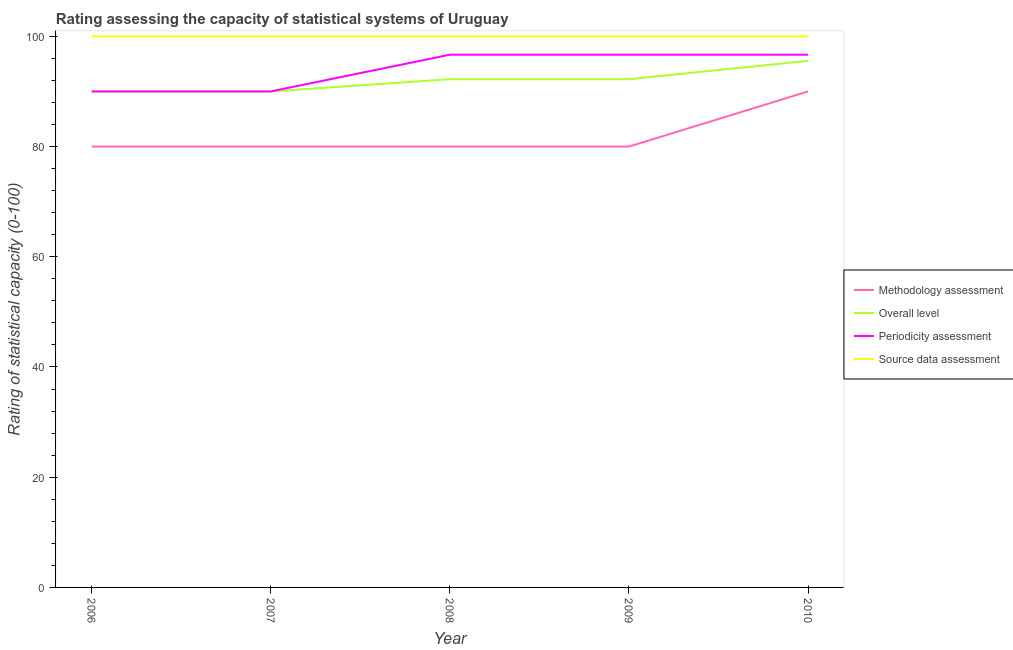How many different coloured lines are there?
Keep it short and to the point. 4. Does the line corresponding to periodicity assessment rating intersect with the line corresponding to source data assessment rating?
Your response must be concise. No. Is the number of lines equal to the number of legend labels?
Your answer should be compact. Yes. What is the overall level rating in 2008?
Give a very brief answer. 92.22. Across all years, what is the maximum overall level rating?
Provide a succinct answer. 95.56. Across all years, what is the minimum methodology assessment rating?
Offer a terse response. 80. In which year was the periodicity assessment rating maximum?
Provide a short and direct response. 2008. In which year was the periodicity assessment rating minimum?
Provide a short and direct response. 2006. What is the total overall level rating in the graph?
Your answer should be very brief. 460. What is the difference between the source data assessment rating in 2006 and that in 2007?
Offer a very short reply. 0. What is the difference between the periodicity assessment rating in 2009 and the overall level rating in 2008?
Ensure brevity in your answer.  4.44. What is the average periodicity assessment rating per year?
Keep it short and to the point. 94. In the year 2008, what is the difference between the periodicity assessment rating and source data assessment rating?
Keep it short and to the point. -3.33. In how many years, is the overall level rating greater than 84?
Provide a short and direct response. 5. What is the ratio of the periodicity assessment rating in 2009 to that in 2010?
Your answer should be very brief. 1. Is the periodicity assessment rating in 2006 less than that in 2009?
Provide a short and direct response. Yes. What is the difference between the highest and the lowest source data assessment rating?
Offer a very short reply. 0. In how many years, is the methodology assessment rating greater than the average methodology assessment rating taken over all years?
Provide a succinct answer. 1. Is it the case that in every year, the sum of the methodology assessment rating and source data assessment rating is greater than the sum of periodicity assessment rating and overall level rating?
Make the answer very short. No. Does the overall level rating monotonically increase over the years?
Provide a succinct answer. No. Is the source data assessment rating strictly greater than the overall level rating over the years?
Offer a very short reply. Yes. Is the source data assessment rating strictly less than the periodicity assessment rating over the years?
Provide a short and direct response. No. How many lines are there?
Offer a very short reply. 4. What is the difference between two consecutive major ticks on the Y-axis?
Offer a very short reply. 20. Does the graph contain any zero values?
Make the answer very short. No. How are the legend labels stacked?
Provide a short and direct response. Vertical. What is the title of the graph?
Give a very brief answer. Rating assessing the capacity of statistical systems of Uruguay. What is the label or title of the X-axis?
Provide a short and direct response. Year. What is the label or title of the Y-axis?
Provide a succinct answer. Rating of statistical capacity (0-100). What is the Rating of statistical capacity (0-100) of Methodology assessment in 2007?
Ensure brevity in your answer.  80. What is the Rating of statistical capacity (0-100) in Periodicity assessment in 2007?
Your answer should be very brief. 90. What is the Rating of statistical capacity (0-100) of Methodology assessment in 2008?
Provide a succinct answer. 80. What is the Rating of statistical capacity (0-100) of Overall level in 2008?
Your answer should be compact. 92.22. What is the Rating of statistical capacity (0-100) of Periodicity assessment in 2008?
Your response must be concise. 96.67. What is the Rating of statistical capacity (0-100) in Methodology assessment in 2009?
Give a very brief answer. 80. What is the Rating of statistical capacity (0-100) in Overall level in 2009?
Provide a succinct answer. 92.22. What is the Rating of statistical capacity (0-100) in Periodicity assessment in 2009?
Provide a succinct answer. 96.67. What is the Rating of statistical capacity (0-100) in Source data assessment in 2009?
Offer a very short reply. 100. What is the Rating of statistical capacity (0-100) of Overall level in 2010?
Keep it short and to the point. 95.56. What is the Rating of statistical capacity (0-100) in Periodicity assessment in 2010?
Your response must be concise. 96.67. What is the Rating of statistical capacity (0-100) of Source data assessment in 2010?
Your response must be concise. 100. Across all years, what is the maximum Rating of statistical capacity (0-100) in Methodology assessment?
Offer a very short reply. 90. Across all years, what is the maximum Rating of statistical capacity (0-100) in Overall level?
Offer a terse response. 95.56. Across all years, what is the maximum Rating of statistical capacity (0-100) in Periodicity assessment?
Offer a terse response. 96.67. Across all years, what is the minimum Rating of statistical capacity (0-100) of Methodology assessment?
Provide a short and direct response. 80. Across all years, what is the minimum Rating of statistical capacity (0-100) of Overall level?
Your answer should be compact. 90. Across all years, what is the minimum Rating of statistical capacity (0-100) in Periodicity assessment?
Your answer should be compact. 90. Across all years, what is the minimum Rating of statistical capacity (0-100) in Source data assessment?
Keep it short and to the point. 100. What is the total Rating of statistical capacity (0-100) of Methodology assessment in the graph?
Make the answer very short. 410. What is the total Rating of statistical capacity (0-100) of Overall level in the graph?
Give a very brief answer. 460. What is the total Rating of statistical capacity (0-100) of Periodicity assessment in the graph?
Offer a terse response. 470. What is the difference between the Rating of statistical capacity (0-100) of Methodology assessment in 2006 and that in 2007?
Make the answer very short. 0. What is the difference between the Rating of statistical capacity (0-100) of Periodicity assessment in 2006 and that in 2007?
Give a very brief answer. 0. What is the difference between the Rating of statistical capacity (0-100) in Overall level in 2006 and that in 2008?
Your answer should be compact. -2.22. What is the difference between the Rating of statistical capacity (0-100) in Periodicity assessment in 2006 and that in 2008?
Provide a succinct answer. -6.67. What is the difference between the Rating of statistical capacity (0-100) in Source data assessment in 2006 and that in 2008?
Give a very brief answer. 0. What is the difference between the Rating of statistical capacity (0-100) in Methodology assessment in 2006 and that in 2009?
Offer a terse response. 0. What is the difference between the Rating of statistical capacity (0-100) in Overall level in 2006 and that in 2009?
Keep it short and to the point. -2.22. What is the difference between the Rating of statistical capacity (0-100) of Periodicity assessment in 2006 and that in 2009?
Offer a terse response. -6.67. What is the difference between the Rating of statistical capacity (0-100) of Source data assessment in 2006 and that in 2009?
Keep it short and to the point. 0. What is the difference between the Rating of statistical capacity (0-100) in Overall level in 2006 and that in 2010?
Offer a terse response. -5.56. What is the difference between the Rating of statistical capacity (0-100) in Periodicity assessment in 2006 and that in 2010?
Ensure brevity in your answer.  -6.67. What is the difference between the Rating of statistical capacity (0-100) in Source data assessment in 2006 and that in 2010?
Make the answer very short. 0. What is the difference between the Rating of statistical capacity (0-100) in Overall level in 2007 and that in 2008?
Keep it short and to the point. -2.22. What is the difference between the Rating of statistical capacity (0-100) of Periodicity assessment in 2007 and that in 2008?
Provide a succinct answer. -6.67. What is the difference between the Rating of statistical capacity (0-100) of Methodology assessment in 2007 and that in 2009?
Provide a short and direct response. 0. What is the difference between the Rating of statistical capacity (0-100) of Overall level in 2007 and that in 2009?
Provide a succinct answer. -2.22. What is the difference between the Rating of statistical capacity (0-100) in Periodicity assessment in 2007 and that in 2009?
Provide a short and direct response. -6.67. What is the difference between the Rating of statistical capacity (0-100) in Methodology assessment in 2007 and that in 2010?
Keep it short and to the point. -10. What is the difference between the Rating of statistical capacity (0-100) of Overall level in 2007 and that in 2010?
Ensure brevity in your answer.  -5.56. What is the difference between the Rating of statistical capacity (0-100) of Periodicity assessment in 2007 and that in 2010?
Your answer should be compact. -6.67. What is the difference between the Rating of statistical capacity (0-100) of Overall level in 2008 and that in 2009?
Ensure brevity in your answer.  0. What is the difference between the Rating of statistical capacity (0-100) in Periodicity assessment in 2008 and that in 2009?
Your answer should be very brief. 0. What is the difference between the Rating of statistical capacity (0-100) of Source data assessment in 2008 and that in 2009?
Keep it short and to the point. 0. What is the difference between the Rating of statistical capacity (0-100) of Methodology assessment in 2008 and that in 2010?
Provide a succinct answer. -10. What is the difference between the Rating of statistical capacity (0-100) in Source data assessment in 2008 and that in 2010?
Keep it short and to the point. 0. What is the difference between the Rating of statistical capacity (0-100) of Methodology assessment in 2009 and that in 2010?
Provide a succinct answer. -10. What is the difference between the Rating of statistical capacity (0-100) of Overall level in 2009 and that in 2010?
Make the answer very short. -3.33. What is the difference between the Rating of statistical capacity (0-100) of Source data assessment in 2009 and that in 2010?
Ensure brevity in your answer.  0. What is the difference between the Rating of statistical capacity (0-100) of Overall level in 2006 and the Rating of statistical capacity (0-100) of Periodicity assessment in 2007?
Provide a succinct answer. 0. What is the difference between the Rating of statistical capacity (0-100) in Overall level in 2006 and the Rating of statistical capacity (0-100) in Source data assessment in 2007?
Offer a very short reply. -10. What is the difference between the Rating of statistical capacity (0-100) of Periodicity assessment in 2006 and the Rating of statistical capacity (0-100) of Source data assessment in 2007?
Provide a succinct answer. -10. What is the difference between the Rating of statistical capacity (0-100) in Methodology assessment in 2006 and the Rating of statistical capacity (0-100) in Overall level in 2008?
Your answer should be compact. -12.22. What is the difference between the Rating of statistical capacity (0-100) of Methodology assessment in 2006 and the Rating of statistical capacity (0-100) of Periodicity assessment in 2008?
Your response must be concise. -16.67. What is the difference between the Rating of statistical capacity (0-100) of Methodology assessment in 2006 and the Rating of statistical capacity (0-100) of Source data assessment in 2008?
Provide a short and direct response. -20. What is the difference between the Rating of statistical capacity (0-100) of Overall level in 2006 and the Rating of statistical capacity (0-100) of Periodicity assessment in 2008?
Your answer should be very brief. -6.67. What is the difference between the Rating of statistical capacity (0-100) in Methodology assessment in 2006 and the Rating of statistical capacity (0-100) in Overall level in 2009?
Provide a succinct answer. -12.22. What is the difference between the Rating of statistical capacity (0-100) in Methodology assessment in 2006 and the Rating of statistical capacity (0-100) in Periodicity assessment in 2009?
Ensure brevity in your answer.  -16.67. What is the difference between the Rating of statistical capacity (0-100) of Methodology assessment in 2006 and the Rating of statistical capacity (0-100) of Source data assessment in 2009?
Keep it short and to the point. -20. What is the difference between the Rating of statistical capacity (0-100) of Overall level in 2006 and the Rating of statistical capacity (0-100) of Periodicity assessment in 2009?
Give a very brief answer. -6.67. What is the difference between the Rating of statistical capacity (0-100) of Overall level in 2006 and the Rating of statistical capacity (0-100) of Source data assessment in 2009?
Give a very brief answer. -10. What is the difference between the Rating of statistical capacity (0-100) in Periodicity assessment in 2006 and the Rating of statistical capacity (0-100) in Source data assessment in 2009?
Provide a short and direct response. -10. What is the difference between the Rating of statistical capacity (0-100) of Methodology assessment in 2006 and the Rating of statistical capacity (0-100) of Overall level in 2010?
Offer a very short reply. -15.56. What is the difference between the Rating of statistical capacity (0-100) in Methodology assessment in 2006 and the Rating of statistical capacity (0-100) in Periodicity assessment in 2010?
Make the answer very short. -16.67. What is the difference between the Rating of statistical capacity (0-100) in Methodology assessment in 2006 and the Rating of statistical capacity (0-100) in Source data assessment in 2010?
Provide a succinct answer. -20. What is the difference between the Rating of statistical capacity (0-100) of Overall level in 2006 and the Rating of statistical capacity (0-100) of Periodicity assessment in 2010?
Offer a very short reply. -6.67. What is the difference between the Rating of statistical capacity (0-100) of Overall level in 2006 and the Rating of statistical capacity (0-100) of Source data assessment in 2010?
Your answer should be very brief. -10. What is the difference between the Rating of statistical capacity (0-100) of Methodology assessment in 2007 and the Rating of statistical capacity (0-100) of Overall level in 2008?
Your answer should be compact. -12.22. What is the difference between the Rating of statistical capacity (0-100) in Methodology assessment in 2007 and the Rating of statistical capacity (0-100) in Periodicity assessment in 2008?
Your response must be concise. -16.67. What is the difference between the Rating of statistical capacity (0-100) of Methodology assessment in 2007 and the Rating of statistical capacity (0-100) of Source data assessment in 2008?
Provide a short and direct response. -20. What is the difference between the Rating of statistical capacity (0-100) of Overall level in 2007 and the Rating of statistical capacity (0-100) of Periodicity assessment in 2008?
Keep it short and to the point. -6.67. What is the difference between the Rating of statistical capacity (0-100) in Overall level in 2007 and the Rating of statistical capacity (0-100) in Source data assessment in 2008?
Offer a very short reply. -10. What is the difference between the Rating of statistical capacity (0-100) of Periodicity assessment in 2007 and the Rating of statistical capacity (0-100) of Source data assessment in 2008?
Keep it short and to the point. -10. What is the difference between the Rating of statistical capacity (0-100) of Methodology assessment in 2007 and the Rating of statistical capacity (0-100) of Overall level in 2009?
Offer a very short reply. -12.22. What is the difference between the Rating of statistical capacity (0-100) in Methodology assessment in 2007 and the Rating of statistical capacity (0-100) in Periodicity assessment in 2009?
Offer a very short reply. -16.67. What is the difference between the Rating of statistical capacity (0-100) in Overall level in 2007 and the Rating of statistical capacity (0-100) in Periodicity assessment in 2009?
Offer a very short reply. -6.67. What is the difference between the Rating of statistical capacity (0-100) in Overall level in 2007 and the Rating of statistical capacity (0-100) in Source data assessment in 2009?
Give a very brief answer. -10. What is the difference between the Rating of statistical capacity (0-100) in Methodology assessment in 2007 and the Rating of statistical capacity (0-100) in Overall level in 2010?
Keep it short and to the point. -15.56. What is the difference between the Rating of statistical capacity (0-100) of Methodology assessment in 2007 and the Rating of statistical capacity (0-100) of Periodicity assessment in 2010?
Offer a terse response. -16.67. What is the difference between the Rating of statistical capacity (0-100) of Methodology assessment in 2007 and the Rating of statistical capacity (0-100) of Source data assessment in 2010?
Provide a short and direct response. -20. What is the difference between the Rating of statistical capacity (0-100) of Overall level in 2007 and the Rating of statistical capacity (0-100) of Periodicity assessment in 2010?
Your answer should be compact. -6.67. What is the difference between the Rating of statistical capacity (0-100) in Methodology assessment in 2008 and the Rating of statistical capacity (0-100) in Overall level in 2009?
Offer a terse response. -12.22. What is the difference between the Rating of statistical capacity (0-100) in Methodology assessment in 2008 and the Rating of statistical capacity (0-100) in Periodicity assessment in 2009?
Offer a terse response. -16.67. What is the difference between the Rating of statistical capacity (0-100) in Overall level in 2008 and the Rating of statistical capacity (0-100) in Periodicity assessment in 2009?
Offer a very short reply. -4.44. What is the difference between the Rating of statistical capacity (0-100) in Overall level in 2008 and the Rating of statistical capacity (0-100) in Source data assessment in 2009?
Ensure brevity in your answer.  -7.78. What is the difference between the Rating of statistical capacity (0-100) of Methodology assessment in 2008 and the Rating of statistical capacity (0-100) of Overall level in 2010?
Your response must be concise. -15.56. What is the difference between the Rating of statistical capacity (0-100) of Methodology assessment in 2008 and the Rating of statistical capacity (0-100) of Periodicity assessment in 2010?
Give a very brief answer. -16.67. What is the difference between the Rating of statistical capacity (0-100) in Methodology assessment in 2008 and the Rating of statistical capacity (0-100) in Source data assessment in 2010?
Provide a succinct answer. -20. What is the difference between the Rating of statistical capacity (0-100) of Overall level in 2008 and the Rating of statistical capacity (0-100) of Periodicity assessment in 2010?
Offer a terse response. -4.44. What is the difference between the Rating of statistical capacity (0-100) in Overall level in 2008 and the Rating of statistical capacity (0-100) in Source data assessment in 2010?
Your answer should be very brief. -7.78. What is the difference between the Rating of statistical capacity (0-100) in Methodology assessment in 2009 and the Rating of statistical capacity (0-100) in Overall level in 2010?
Your answer should be compact. -15.56. What is the difference between the Rating of statistical capacity (0-100) in Methodology assessment in 2009 and the Rating of statistical capacity (0-100) in Periodicity assessment in 2010?
Your response must be concise. -16.67. What is the difference between the Rating of statistical capacity (0-100) of Methodology assessment in 2009 and the Rating of statistical capacity (0-100) of Source data assessment in 2010?
Offer a very short reply. -20. What is the difference between the Rating of statistical capacity (0-100) of Overall level in 2009 and the Rating of statistical capacity (0-100) of Periodicity assessment in 2010?
Your answer should be very brief. -4.44. What is the difference between the Rating of statistical capacity (0-100) of Overall level in 2009 and the Rating of statistical capacity (0-100) of Source data assessment in 2010?
Make the answer very short. -7.78. What is the difference between the Rating of statistical capacity (0-100) in Periodicity assessment in 2009 and the Rating of statistical capacity (0-100) in Source data assessment in 2010?
Your response must be concise. -3.33. What is the average Rating of statistical capacity (0-100) in Overall level per year?
Ensure brevity in your answer.  92. What is the average Rating of statistical capacity (0-100) of Periodicity assessment per year?
Keep it short and to the point. 94. What is the average Rating of statistical capacity (0-100) of Source data assessment per year?
Your answer should be very brief. 100. In the year 2006, what is the difference between the Rating of statistical capacity (0-100) of Methodology assessment and Rating of statistical capacity (0-100) of Overall level?
Ensure brevity in your answer.  -10. In the year 2006, what is the difference between the Rating of statistical capacity (0-100) in Methodology assessment and Rating of statistical capacity (0-100) in Source data assessment?
Offer a very short reply. -20. In the year 2007, what is the difference between the Rating of statistical capacity (0-100) of Methodology assessment and Rating of statistical capacity (0-100) of Overall level?
Your answer should be compact. -10. In the year 2007, what is the difference between the Rating of statistical capacity (0-100) in Methodology assessment and Rating of statistical capacity (0-100) in Periodicity assessment?
Give a very brief answer. -10. In the year 2007, what is the difference between the Rating of statistical capacity (0-100) of Methodology assessment and Rating of statistical capacity (0-100) of Source data assessment?
Keep it short and to the point. -20. In the year 2007, what is the difference between the Rating of statistical capacity (0-100) in Overall level and Rating of statistical capacity (0-100) in Periodicity assessment?
Offer a terse response. 0. In the year 2008, what is the difference between the Rating of statistical capacity (0-100) of Methodology assessment and Rating of statistical capacity (0-100) of Overall level?
Offer a very short reply. -12.22. In the year 2008, what is the difference between the Rating of statistical capacity (0-100) of Methodology assessment and Rating of statistical capacity (0-100) of Periodicity assessment?
Your answer should be compact. -16.67. In the year 2008, what is the difference between the Rating of statistical capacity (0-100) of Methodology assessment and Rating of statistical capacity (0-100) of Source data assessment?
Give a very brief answer. -20. In the year 2008, what is the difference between the Rating of statistical capacity (0-100) in Overall level and Rating of statistical capacity (0-100) in Periodicity assessment?
Provide a succinct answer. -4.44. In the year 2008, what is the difference between the Rating of statistical capacity (0-100) in Overall level and Rating of statistical capacity (0-100) in Source data assessment?
Your answer should be compact. -7.78. In the year 2009, what is the difference between the Rating of statistical capacity (0-100) in Methodology assessment and Rating of statistical capacity (0-100) in Overall level?
Your response must be concise. -12.22. In the year 2009, what is the difference between the Rating of statistical capacity (0-100) in Methodology assessment and Rating of statistical capacity (0-100) in Periodicity assessment?
Your response must be concise. -16.67. In the year 2009, what is the difference between the Rating of statistical capacity (0-100) in Overall level and Rating of statistical capacity (0-100) in Periodicity assessment?
Your answer should be very brief. -4.44. In the year 2009, what is the difference between the Rating of statistical capacity (0-100) in Overall level and Rating of statistical capacity (0-100) in Source data assessment?
Your response must be concise. -7.78. In the year 2009, what is the difference between the Rating of statistical capacity (0-100) of Periodicity assessment and Rating of statistical capacity (0-100) of Source data assessment?
Offer a very short reply. -3.33. In the year 2010, what is the difference between the Rating of statistical capacity (0-100) of Methodology assessment and Rating of statistical capacity (0-100) of Overall level?
Ensure brevity in your answer.  -5.56. In the year 2010, what is the difference between the Rating of statistical capacity (0-100) in Methodology assessment and Rating of statistical capacity (0-100) in Periodicity assessment?
Your answer should be compact. -6.67. In the year 2010, what is the difference between the Rating of statistical capacity (0-100) of Methodology assessment and Rating of statistical capacity (0-100) of Source data assessment?
Your answer should be compact. -10. In the year 2010, what is the difference between the Rating of statistical capacity (0-100) of Overall level and Rating of statistical capacity (0-100) of Periodicity assessment?
Your response must be concise. -1.11. In the year 2010, what is the difference between the Rating of statistical capacity (0-100) of Overall level and Rating of statistical capacity (0-100) of Source data assessment?
Your answer should be compact. -4.44. In the year 2010, what is the difference between the Rating of statistical capacity (0-100) of Periodicity assessment and Rating of statistical capacity (0-100) of Source data assessment?
Keep it short and to the point. -3.33. What is the ratio of the Rating of statistical capacity (0-100) of Overall level in 2006 to that in 2007?
Provide a succinct answer. 1. What is the ratio of the Rating of statistical capacity (0-100) in Periodicity assessment in 2006 to that in 2007?
Offer a very short reply. 1. What is the ratio of the Rating of statistical capacity (0-100) in Methodology assessment in 2006 to that in 2008?
Your answer should be very brief. 1. What is the ratio of the Rating of statistical capacity (0-100) in Overall level in 2006 to that in 2008?
Give a very brief answer. 0.98. What is the ratio of the Rating of statistical capacity (0-100) in Overall level in 2006 to that in 2009?
Your response must be concise. 0.98. What is the ratio of the Rating of statistical capacity (0-100) of Methodology assessment in 2006 to that in 2010?
Give a very brief answer. 0.89. What is the ratio of the Rating of statistical capacity (0-100) in Overall level in 2006 to that in 2010?
Offer a very short reply. 0.94. What is the ratio of the Rating of statistical capacity (0-100) of Periodicity assessment in 2006 to that in 2010?
Offer a very short reply. 0.93. What is the ratio of the Rating of statistical capacity (0-100) in Source data assessment in 2006 to that in 2010?
Your response must be concise. 1. What is the ratio of the Rating of statistical capacity (0-100) of Overall level in 2007 to that in 2008?
Give a very brief answer. 0.98. What is the ratio of the Rating of statistical capacity (0-100) of Overall level in 2007 to that in 2009?
Your answer should be compact. 0.98. What is the ratio of the Rating of statistical capacity (0-100) of Periodicity assessment in 2007 to that in 2009?
Provide a short and direct response. 0.93. What is the ratio of the Rating of statistical capacity (0-100) in Methodology assessment in 2007 to that in 2010?
Give a very brief answer. 0.89. What is the ratio of the Rating of statistical capacity (0-100) in Overall level in 2007 to that in 2010?
Ensure brevity in your answer.  0.94. What is the ratio of the Rating of statistical capacity (0-100) in Periodicity assessment in 2007 to that in 2010?
Ensure brevity in your answer.  0.93. What is the ratio of the Rating of statistical capacity (0-100) in Source data assessment in 2007 to that in 2010?
Offer a very short reply. 1. What is the ratio of the Rating of statistical capacity (0-100) of Methodology assessment in 2008 to that in 2009?
Provide a short and direct response. 1. What is the ratio of the Rating of statistical capacity (0-100) in Methodology assessment in 2008 to that in 2010?
Keep it short and to the point. 0.89. What is the ratio of the Rating of statistical capacity (0-100) of Overall level in 2008 to that in 2010?
Offer a terse response. 0.97. What is the ratio of the Rating of statistical capacity (0-100) of Overall level in 2009 to that in 2010?
Provide a short and direct response. 0.97. What is the difference between the highest and the second highest Rating of statistical capacity (0-100) of Methodology assessment?
Provide a succinct answer. 10. What is the difference between the highest and the second highest Rating of statistical capacity (0-100) of Source data assessment?
Ensure brevity in your answer.  0. What is the difference between the highest and the lowest Rating of statistical capacity (0-100) of Overall level?
Your answer should be compact. 5.56. What is the difference between the highest and the lowest Rating of statistical capacity (0-100) in Source data assessment?
Provide a succinct answer. 0. 